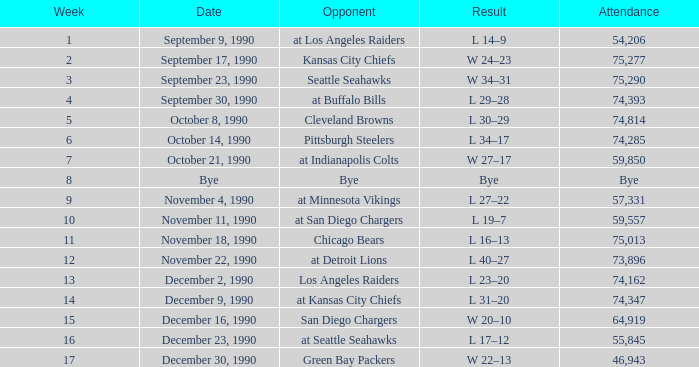What was the result for week 16? L 17–12. 